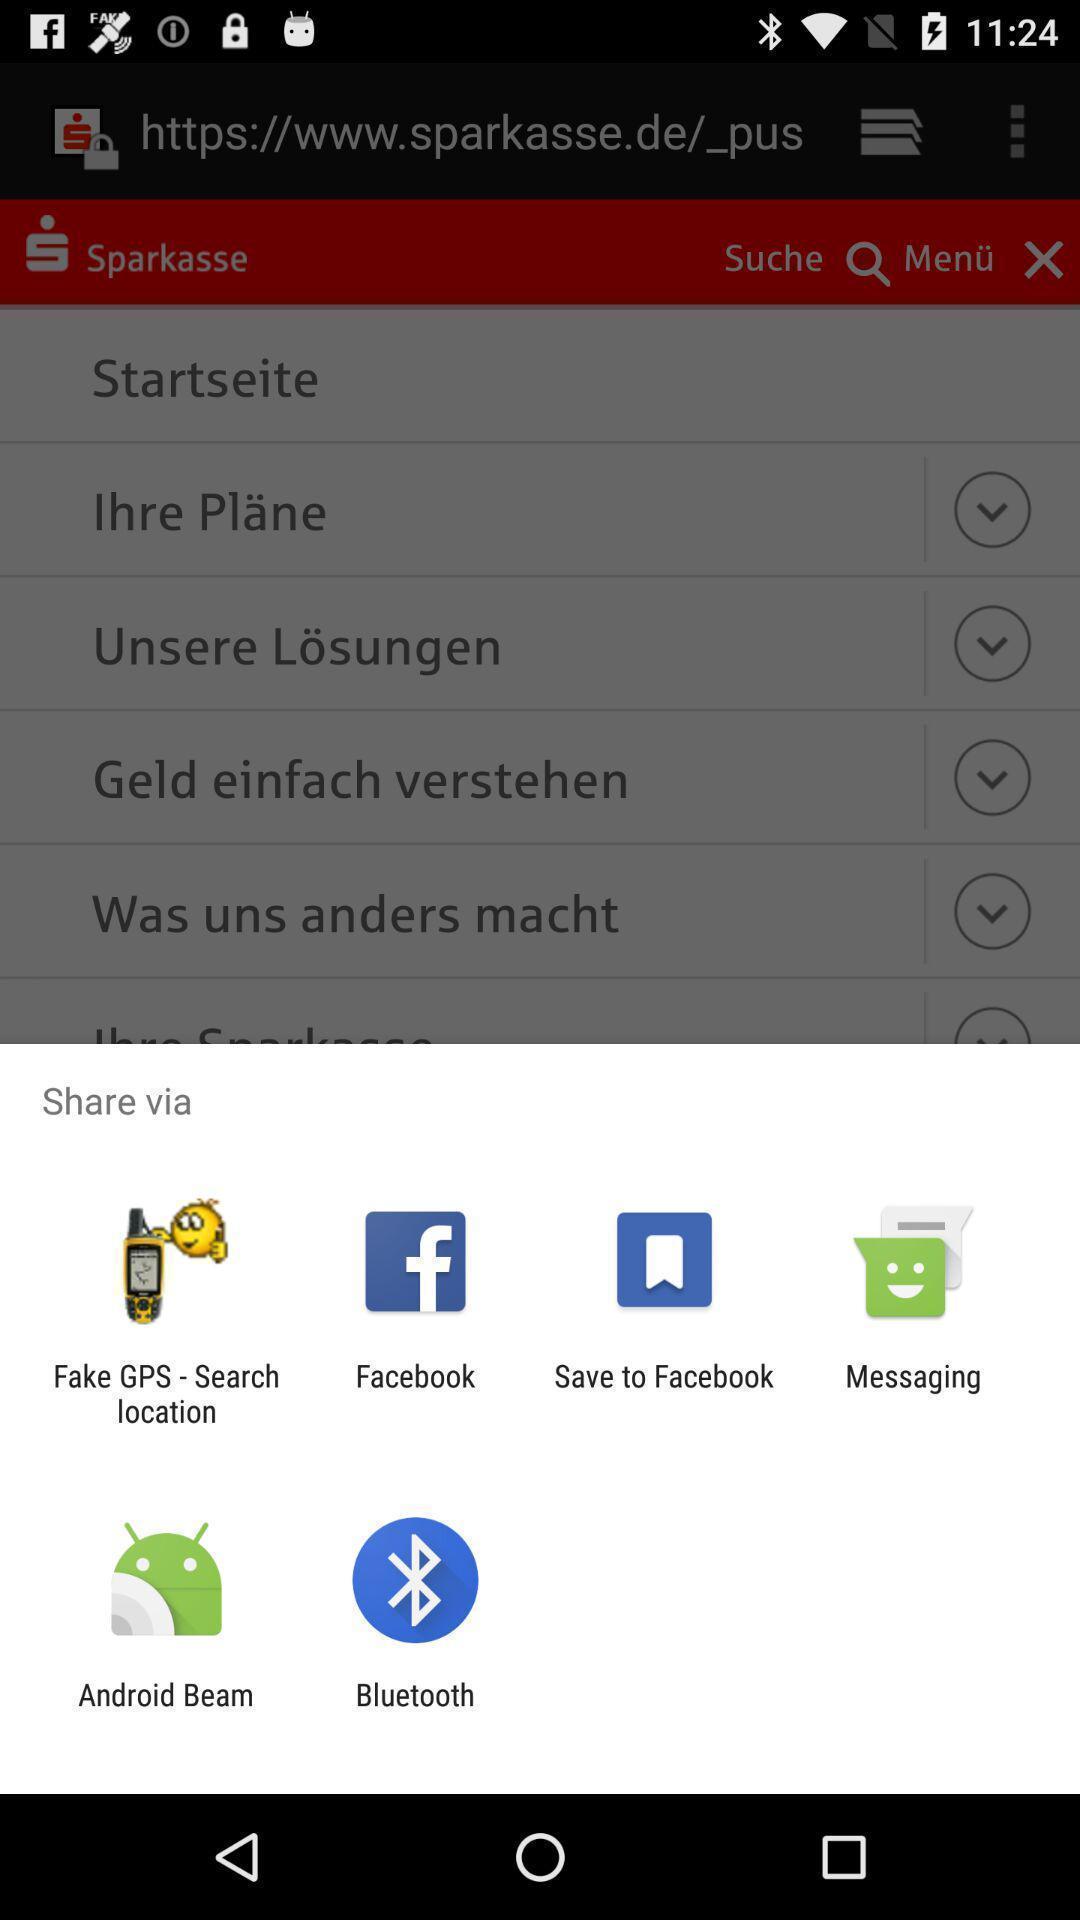Tell me about the visual elements in this screen capture. Pop-up with list of sharing options. 